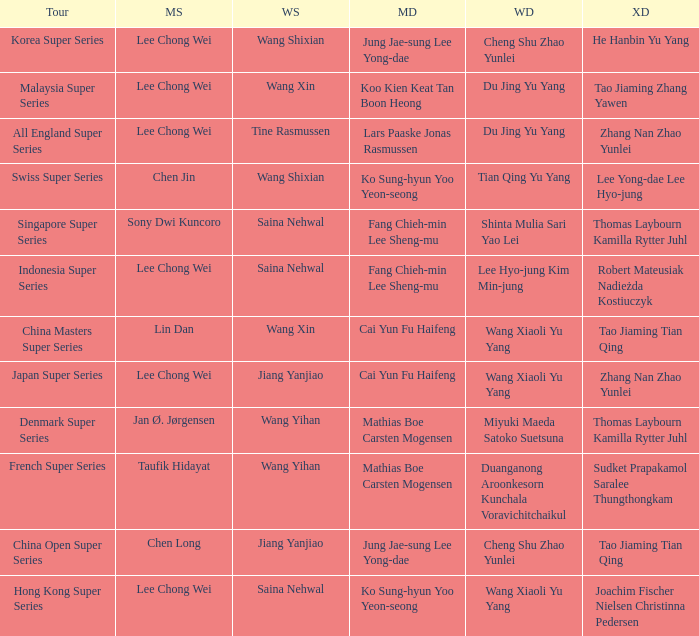Who is the mixed doubled on the tour korea super series? He Hanbin Yu Yang. 